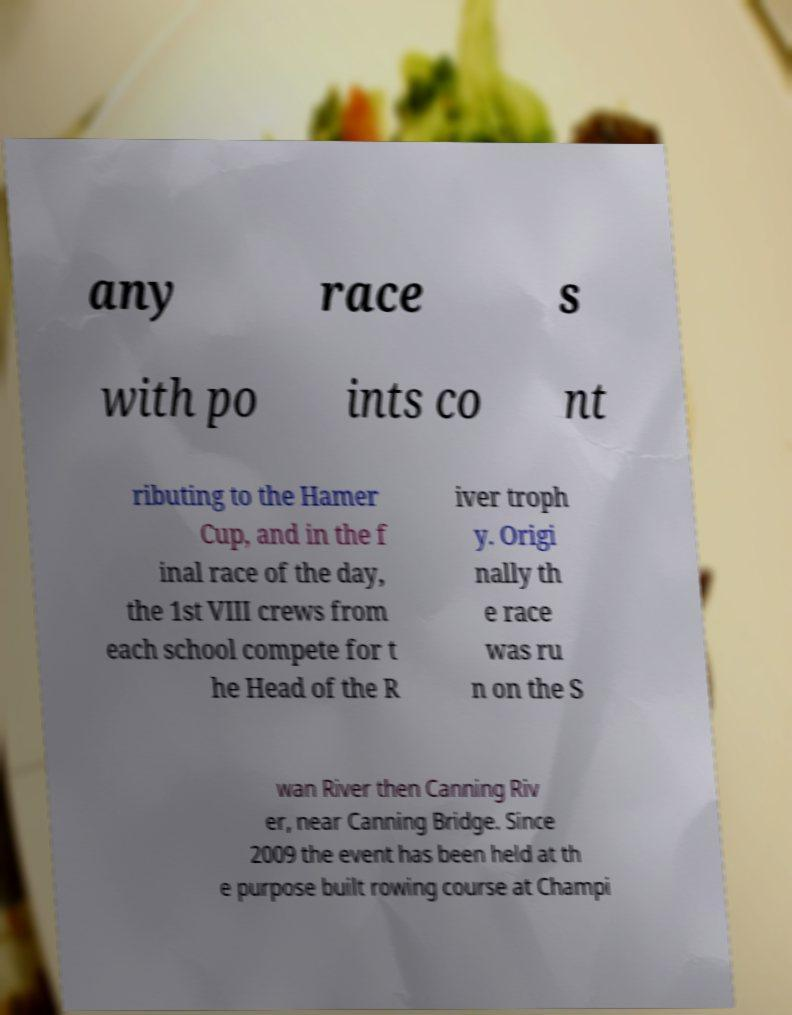Please read and relay the text visible in this image. What does it say? any race s with po ints co nt ributing to the Hamer Cup, and in the f inal race of the day, the 1st VIII crews from each school compete for t he Head of the R iver troph y. Origi nally th e race was ru n on the S wan River then Canning Riv er, near Canning Bridge. Since 2009 the event has been held at th e purpose built rowing course at Champi 